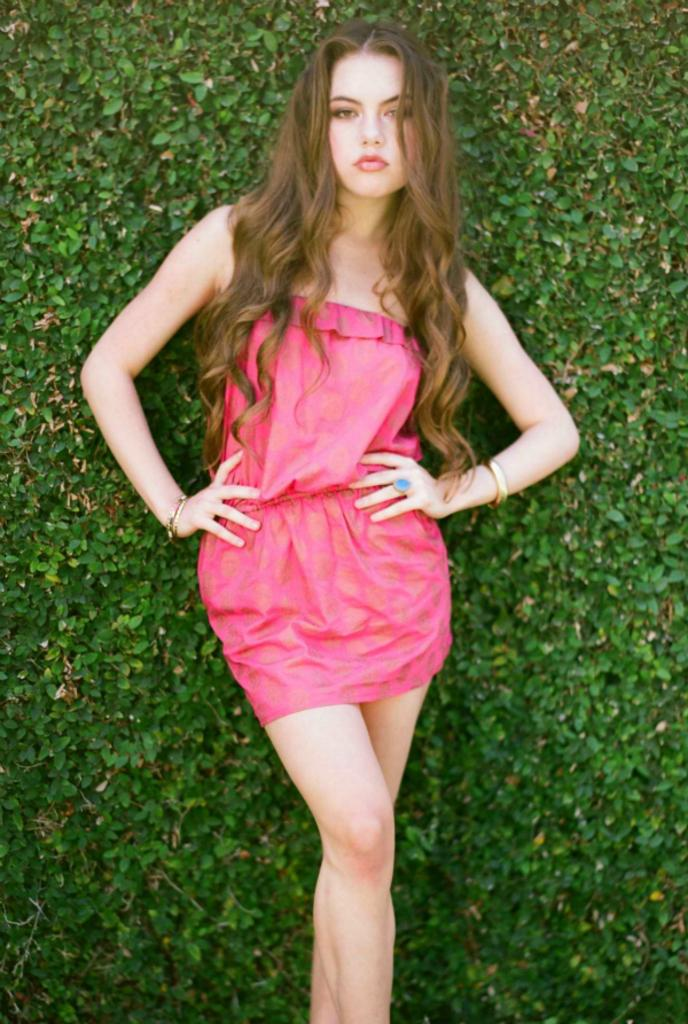Where was the image taken? The image was taken outdoors. What can be seen in the background of the image? There is a creeper with green leaves in the background. Who is the main subject in the image? A girl is standing in the middle of the image. What is a noticeable feature of the girl's appearance? The girl has long hair. What type of riddle is the girl trying to solve in the image? There is no riddle present in the image, and the girl is not shown attempting to solve one. What art medium is the girl using to draw on the ground in the image? There is no art or drawing activity depicted in the image, so it is not possible to determine the medium being used. 